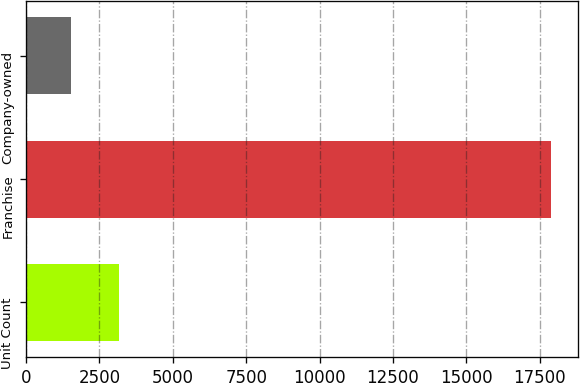Convert chart to OTSL. <chart><loc_0><loc_0><loc_500><loc_500><bar_chart><fcel>Unit Count<fcel>Franchise<fcel>Company-owned<nl><fcel>3162.8<fcel>17894<fcel>1526<nl></chart> 